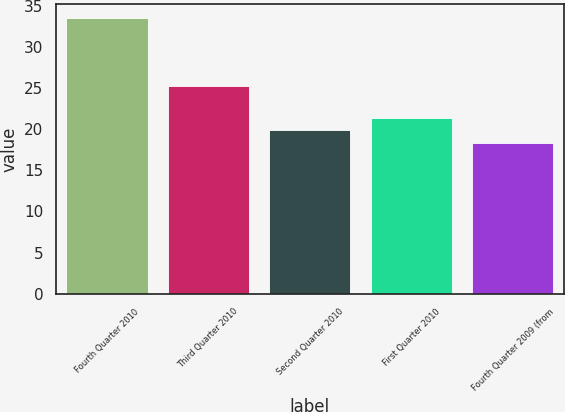<chart> <loc_0><loc_0><loc_500><loc_500><bar_chart><fcel>Fourth Quarter 2010<fcel>Third Quarter 2010<fcel>Second Quarter 2010<fcel>First Quarter 2010<fcel>Fourth Quarter 2009 (from<nl><fcel>33.46<fcel>25.21<fcel>19.87<fcel>21.38<fcel>18.36<nl></chart> 